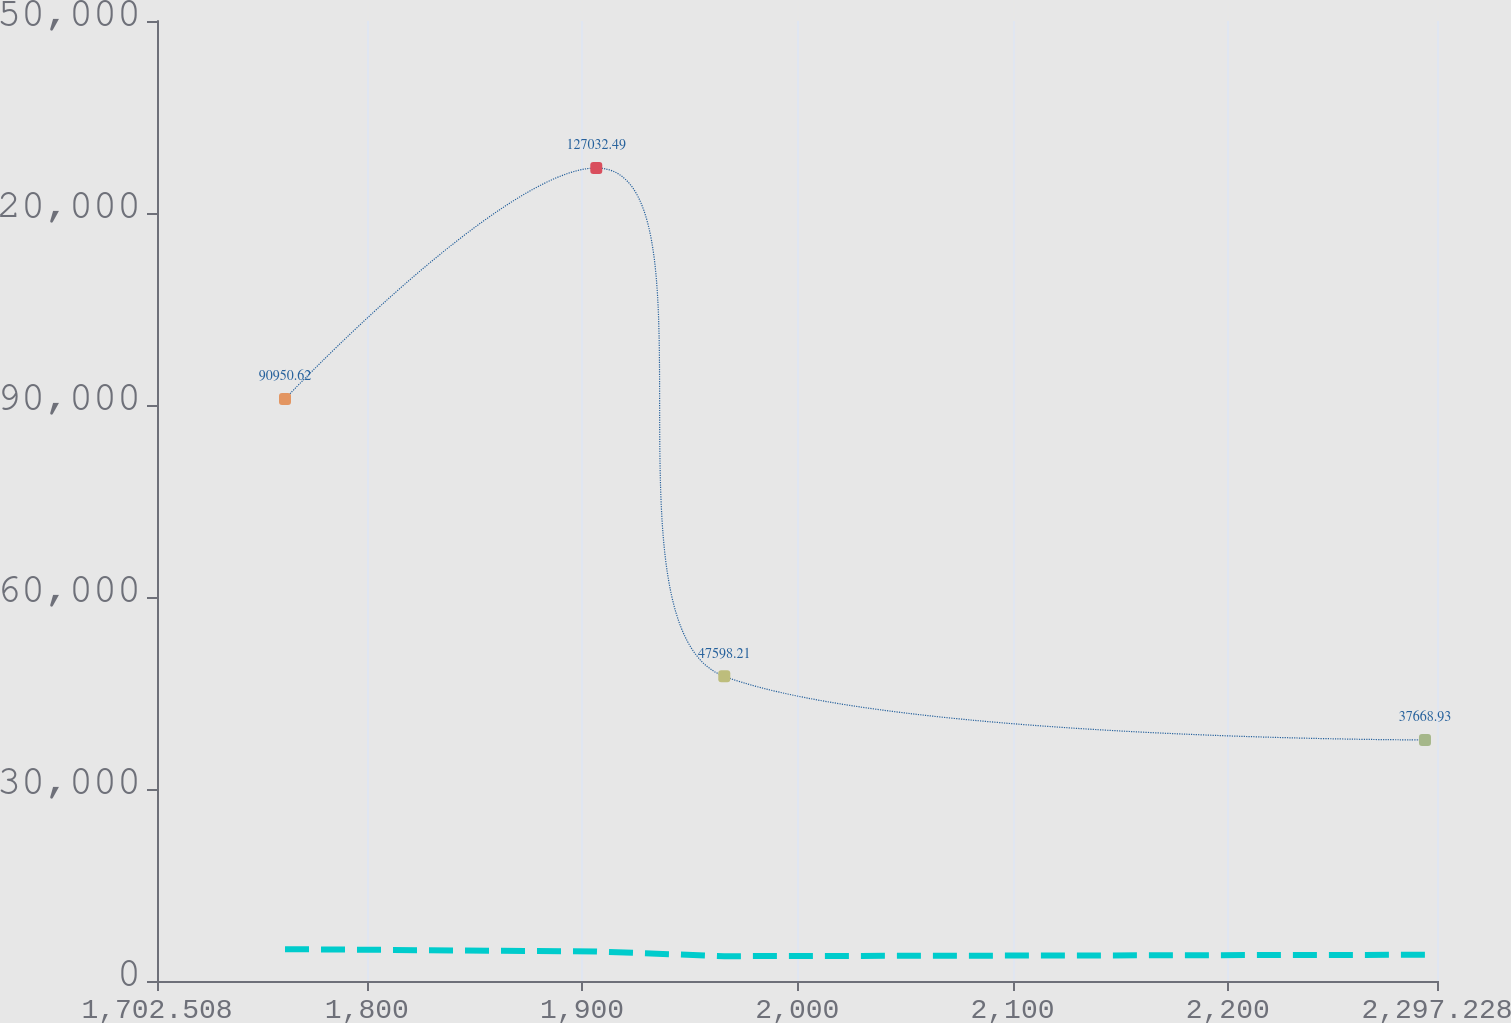Convert chart. <chart><loc_0><loc_0><loc_500><loc_500><line_chart><ecel><fcel>Capital Leases<fcel>Operating Leases<nl><fcel>1761.98<fcel>90950.6<fcel>4977.16<nl><fcel>1906.61<fcel>127032<fcel>4609.01<nl><fcel>1966.08<fcel>47598.2<fcel>3881.26<nl><fcel>2291.64<fcel>37668.9<fcel>4099.26<nl><fcel>2356.7<fcel>27739.7<fcel>5091.21<nl></chart> 